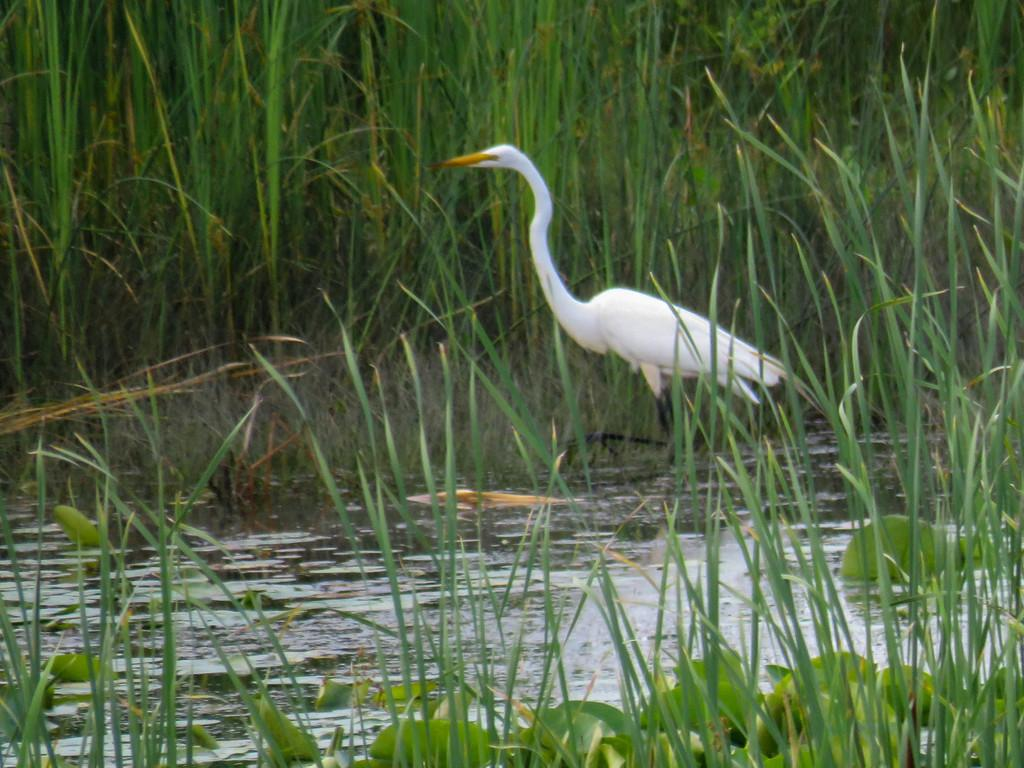What type of animal can be seen in the picture? There is a bird in the picture. What is the primary element in which the bird is situated? The bird is situated in water. What type of vegetation is visible in the picture? There is grass in the picture. What direction does the bird need to go to get approval from the wrist in the image? There is no wrist or approval process present in the image; it features a bird in water with grass. 